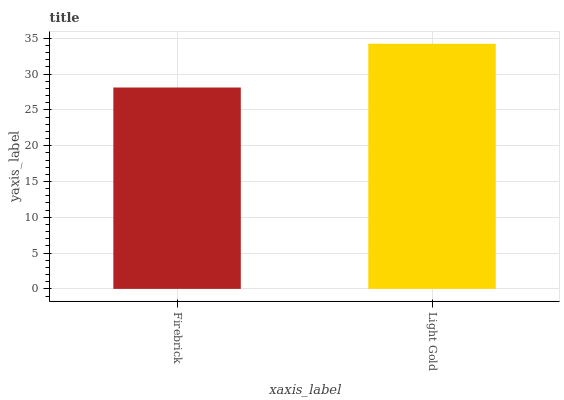Is Firebrick the minimum?
Answer yes or no. Yes. Is Light Gold the maximum?
Answer yes or no. Yes. Is Light Gold the minimum?
Answer yes or no. No. Is Light Gold greater than Firebrick?
Answer yes or no. Yes. Is Firebrick less than Light Gold?
Answer yes or no. Yes. Is Firebrick greater than Light Gold?
Answer yes or no. No. Is Light Gold less than Firebrick?
Answer yes or no. No. Is Light Gold the high median?
Answer yes or no. Yes. Is Firebrick the low median?
Answer yes or no. Yes. Is Firebrick the high median?
Answer yes or no. No. Is Light Gold the low median?
Answer yes or no. No. 